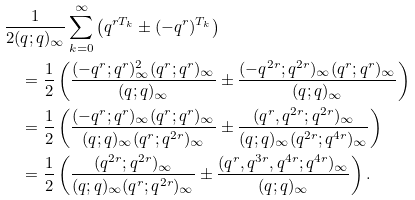<formula> <loc_0><loc_0><loc_500><loc_500>& \frac { 1 } { 2 ( q ; q ) _ { \infty } } \sum _ { k = 0 } ^ { \infty } \left ( q ^ { r T _ { k } } \pm ( - q ^ { r } ) ^ { T _ { k } } \right ) \\ & \quad = \frac { 1 } { 2 } \left ( \frac { ( - q ^ { r } ; q ^ { r } ) ^ { 2 } _ { \infty } ( q ^ { r } ; q ^ { r } ) _ { \infty } } { ( q ; q ) _ { \infty } } \pm \frac { ( - q ^ { 2 r } ; q ^ { 2 r } ) _ { \infty } ( q ^ { r } ; q ^ { r } ) _ { \infty } } { ( q ; q ) _ { \infty } } \right ) \\ & \quad = \frac { 1 } { 2 } \left ( \frac { ( - q ^ { r } ; q ^ { r } ) _ { \infty } ( q ^ { r } ; q ^ { r } ) _ { \infty } } { ( q ; q ) _ { \infty } ( q ^ { r } ; q ^ { 2 r } ) _ { \infty } } \pm \frac { ( q ^ { r } , q ^ { 2 r } ; q ^ { 2 r } ) _ { \infty } } { ( q ; q ) _ { \infty } ( q ^ { 2 r } ; q ^ { 4 r } ) _ { \infty } } \right ) \\ & \quad = \frac { 1 } { 2 } \left ( \frac { ( q ^ { 2 r } ; q ^ { 2 r } ) _ { \infty } } { ( q ; q ) _ { \infty } ( q ^ { r } ; q ^ { 2 r } ) _ { \infty } } \pm \frac { ( q ^ { r } , q ^ { 3 r } , q ^ { 4 r } ; q ^ { 4 r } ) _ { \infty } } { ( q ; q ) _ { \infty } } \right ) .</formula> 